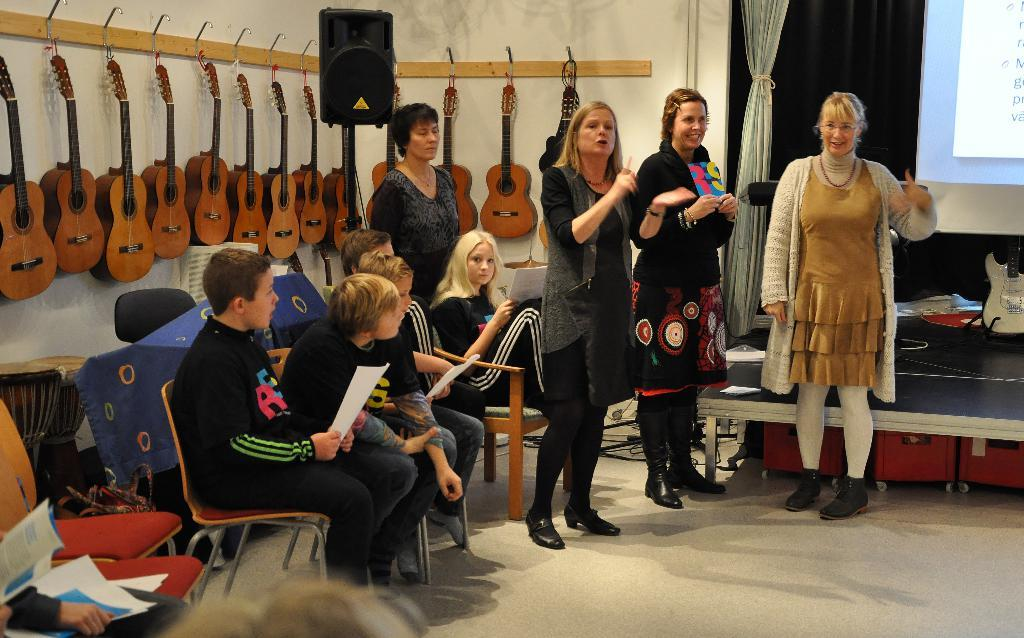What are the people in the image doing? There are people sitting on chairs and standing in the image. Can you describe the background of the image? In the background of the image, there are guitars hanged on the wall. How many nuts are falling from the tree in the image? There is no tree or nuts present in the image; it features people sitting and standing with guitars hanging on the wall in the background. 